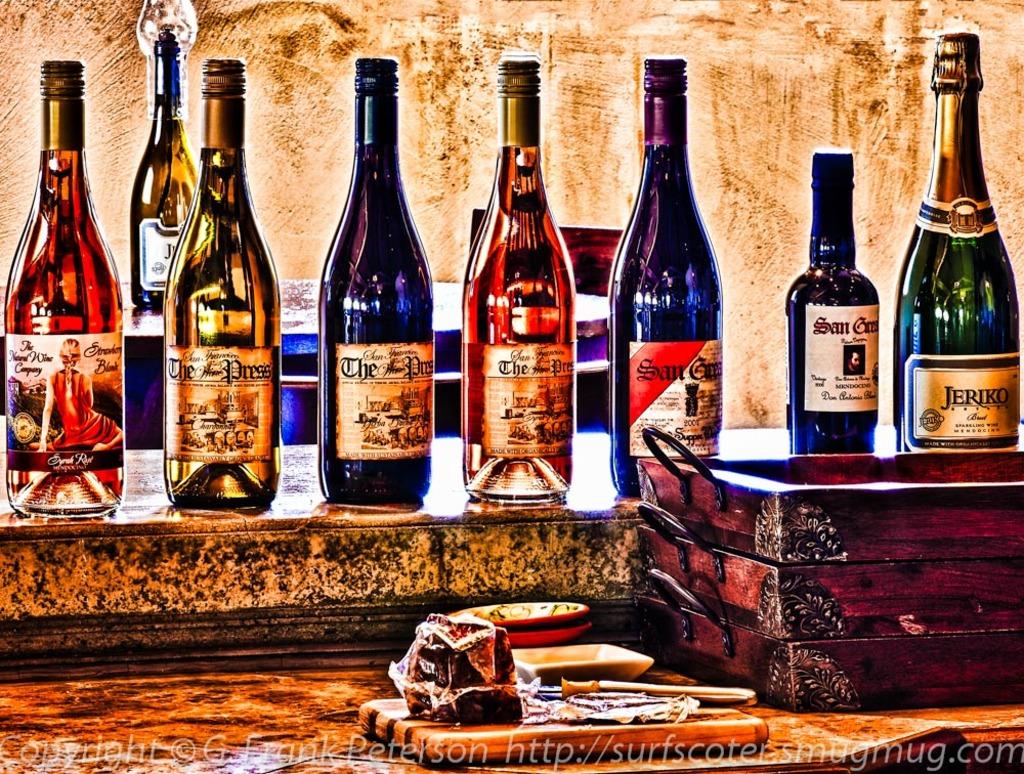Are those wine bottles?
Your response must be concise. Yes. 